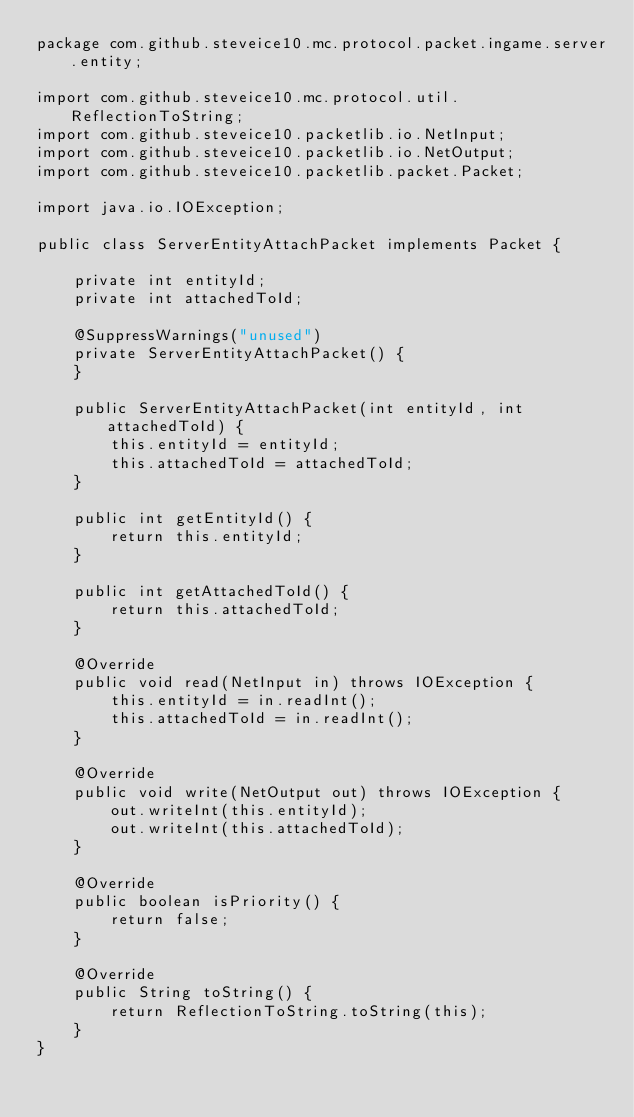Convert code to text. <code><loc_0><loc_0><loc_500><loc_500><_Java_>package com.github.steveice10.mc.protocol.packet.ingame.server.entity;

import com.github.steveice10.mc.protocol.util.ReflectionToString;
import com.github.steveice10.packetlib.io.NetInput;
import com.github.steveice10.packetlib.io.NetOutput;
import com.github.steveice10.packetlib.packet.Packet;

import java.io.IOException;

public class ServerEntityAttachPacket implements Packet {

    private int entityId;
    private int attachedToId;

    @SuppressWarnings("unused")
    private ServerEntityAttachPacket() {
    }

    public ServerEntityAttachPacket(int entityId, int attachedToId) {
        this.entityId = entityId;
        this.attachedToId = attachedToId;
    }

    public int getEntityId() {
        return this.entityId;
    }

    public int getAttachedToId() {
        return this.attachedToId;
    }

    @Override
    public void read(NetInput in) throws IOException {
        this.entityId = in.readInt();
        this.attachedToId = in.readInt();
    }

    @Override
    public void write(NetOutput out) throws IOException {
        out.writeInt(this.entityId);
        out.writeInt(this.attachedToId);
    }

    @Override
    public boolean isPriority() {
        return false;
    }

    @Override
    public String toString() {
        return ReflectionToString.toString(this);
    }
}
</code> 